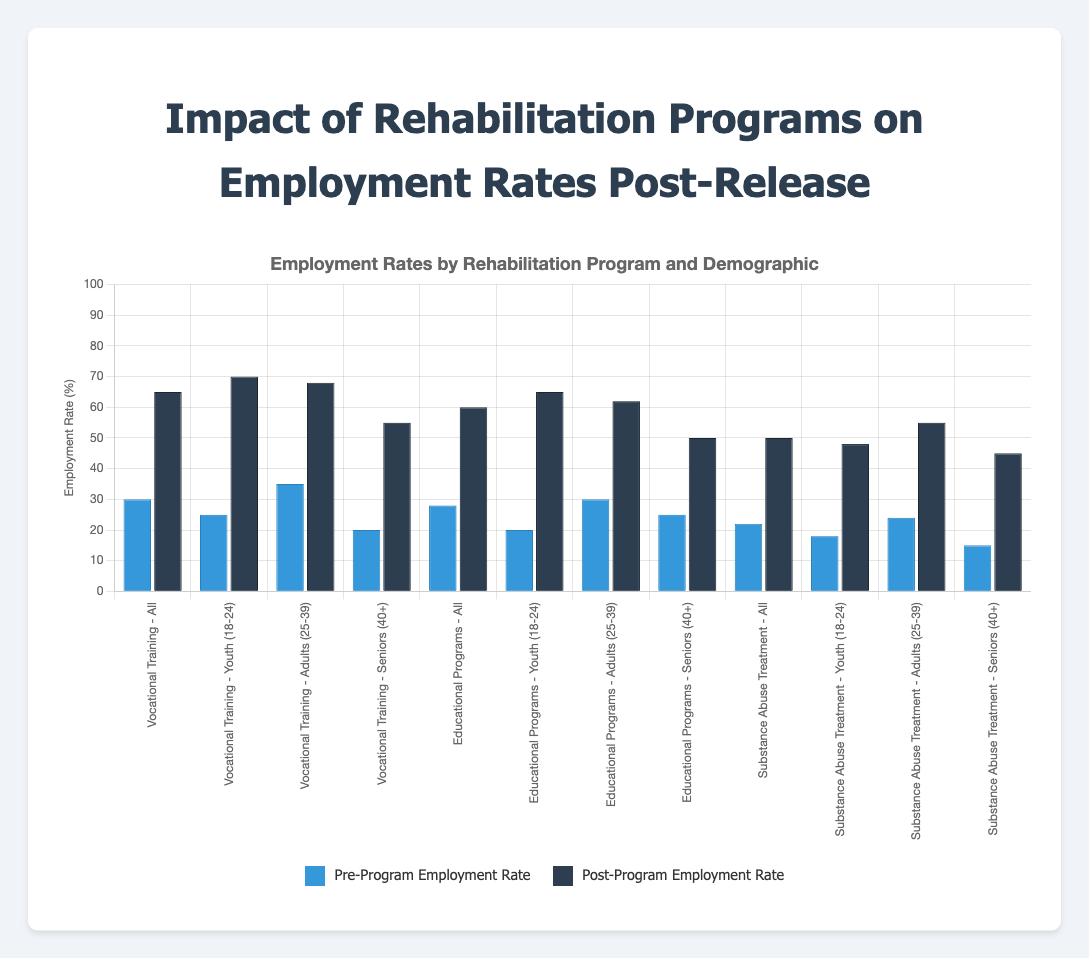What is the employment rate increase for "Vocational Training" for "Youth (18-24)" post-program? The pre-program employment rate for "Vocational Training" for "Youth (18-24)" is 25%, and the post-program employment rate is 70%. The increase is 70% - 25% = 45%.
Answer: 45% Which demographic had the highest employment rate post-program in "Substance Abuse Treatment"? To find the highest post-program employment rate in "Substance Abuse Treatment," compare the post-program rates for each demographic: Youth (18-24) - 48%, Adults (25-39) - 55%, Seniors (40+) - 45%. The highest rate is 55% for Adults (25-39).
Answer: Adults (25-39) Compare the post-program employment rates of "Educational Programs" for "All" and "Youth (18-24)" demographics. Which is higher and by how much? The post-program employment rate for "Educational Programs" for "All" is 60%, and for "Youth (18-24)" is 65%. The "Youth (18-24)" rate is higher by 65% - 60% = 5%.
Answer: Youth (18-24) by 5% For which "Vocational Training" demographic did the employment rate increase the least post-program? To find the least increase in "Vocational Training," calculate the increases: All - (65%-30%=35%), Youth (18-24) - (70%-25%=45%), Adults (25-39) - (68%-35%=33%), Seniors (40+) - (55%-20%=35%). The smallest increase is for Adults (25-39) with 33%.
Answer: Adults (25-39) What is the combined post-program employment rate for "Seniors (40+)" in "Educational Programs" and "Substance Abuse Treatment"? The post-program employment rates are 50% for "Educational Programs" and 45% for "Substance Abuse Treatment". Combined rate = 50% + 45% = 95%.
Answer: 95% Which rehabilitation program shows the highest overall increase in employment rates for the "All" demographic? Compare the overall increases for the "All" demographic: Vocational Training (65%-30%=35%), Educational Programs (60%-28%=32%), Substance Abuse Treatment (50%-22%=28%). The highest increase is for Vocational Training with 35%.
Answer: Vocational Training What is the difference in pre-program employment rates between "Vocational Training" and "Substance Abuse Treatment" for "Adults (25-39)"? The pre-program employment rates are 35% for "Vocational Training" and 24% for "Substance Abuse Treatment". The difference is 35% - 24% = 11%.
Answer: 11% 